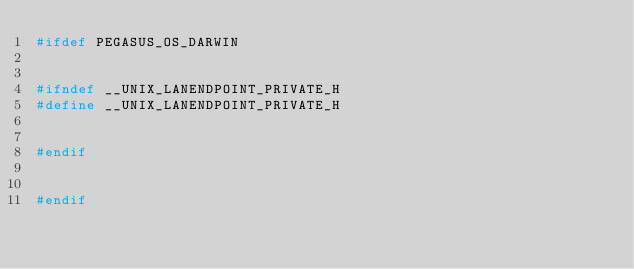Convert code to text. <code><loc_0><loc_0><loc_500><loc_500><_C++_>#ifdef PEGASUS_OS_DARWIN


#ifndef __UNIX_LANENDPOINT_PRIVATE_H
#define __UNIX_LANENDPOINT_PRIVATE_H


#endif


#endif
</code> 